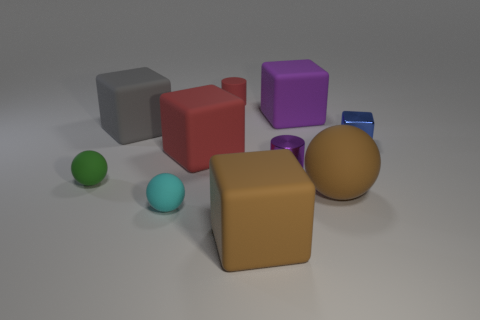Subtract all tiny spheres. How many spheres are left? 1 Subtract all brown cubes. How many cubes are left? 4 Subtract all cyan cylinders. How many gray blocks are left? 1 Subtract all cylinders. How many objects are left? 8 Subtract all blue cylinders. Subtract all cyan balls. How many cylinders are left? 2 Subtract all big blue rubber things. Subtract all big brown spheres. How many objects are left? 9 Add 4 large red blocks. How many large red blocks are left? 5 Add 6 large brown matte objects. How many large brown matte objects exist? 8 Subtract 0 gray cylinders. How many objects are left? 10 